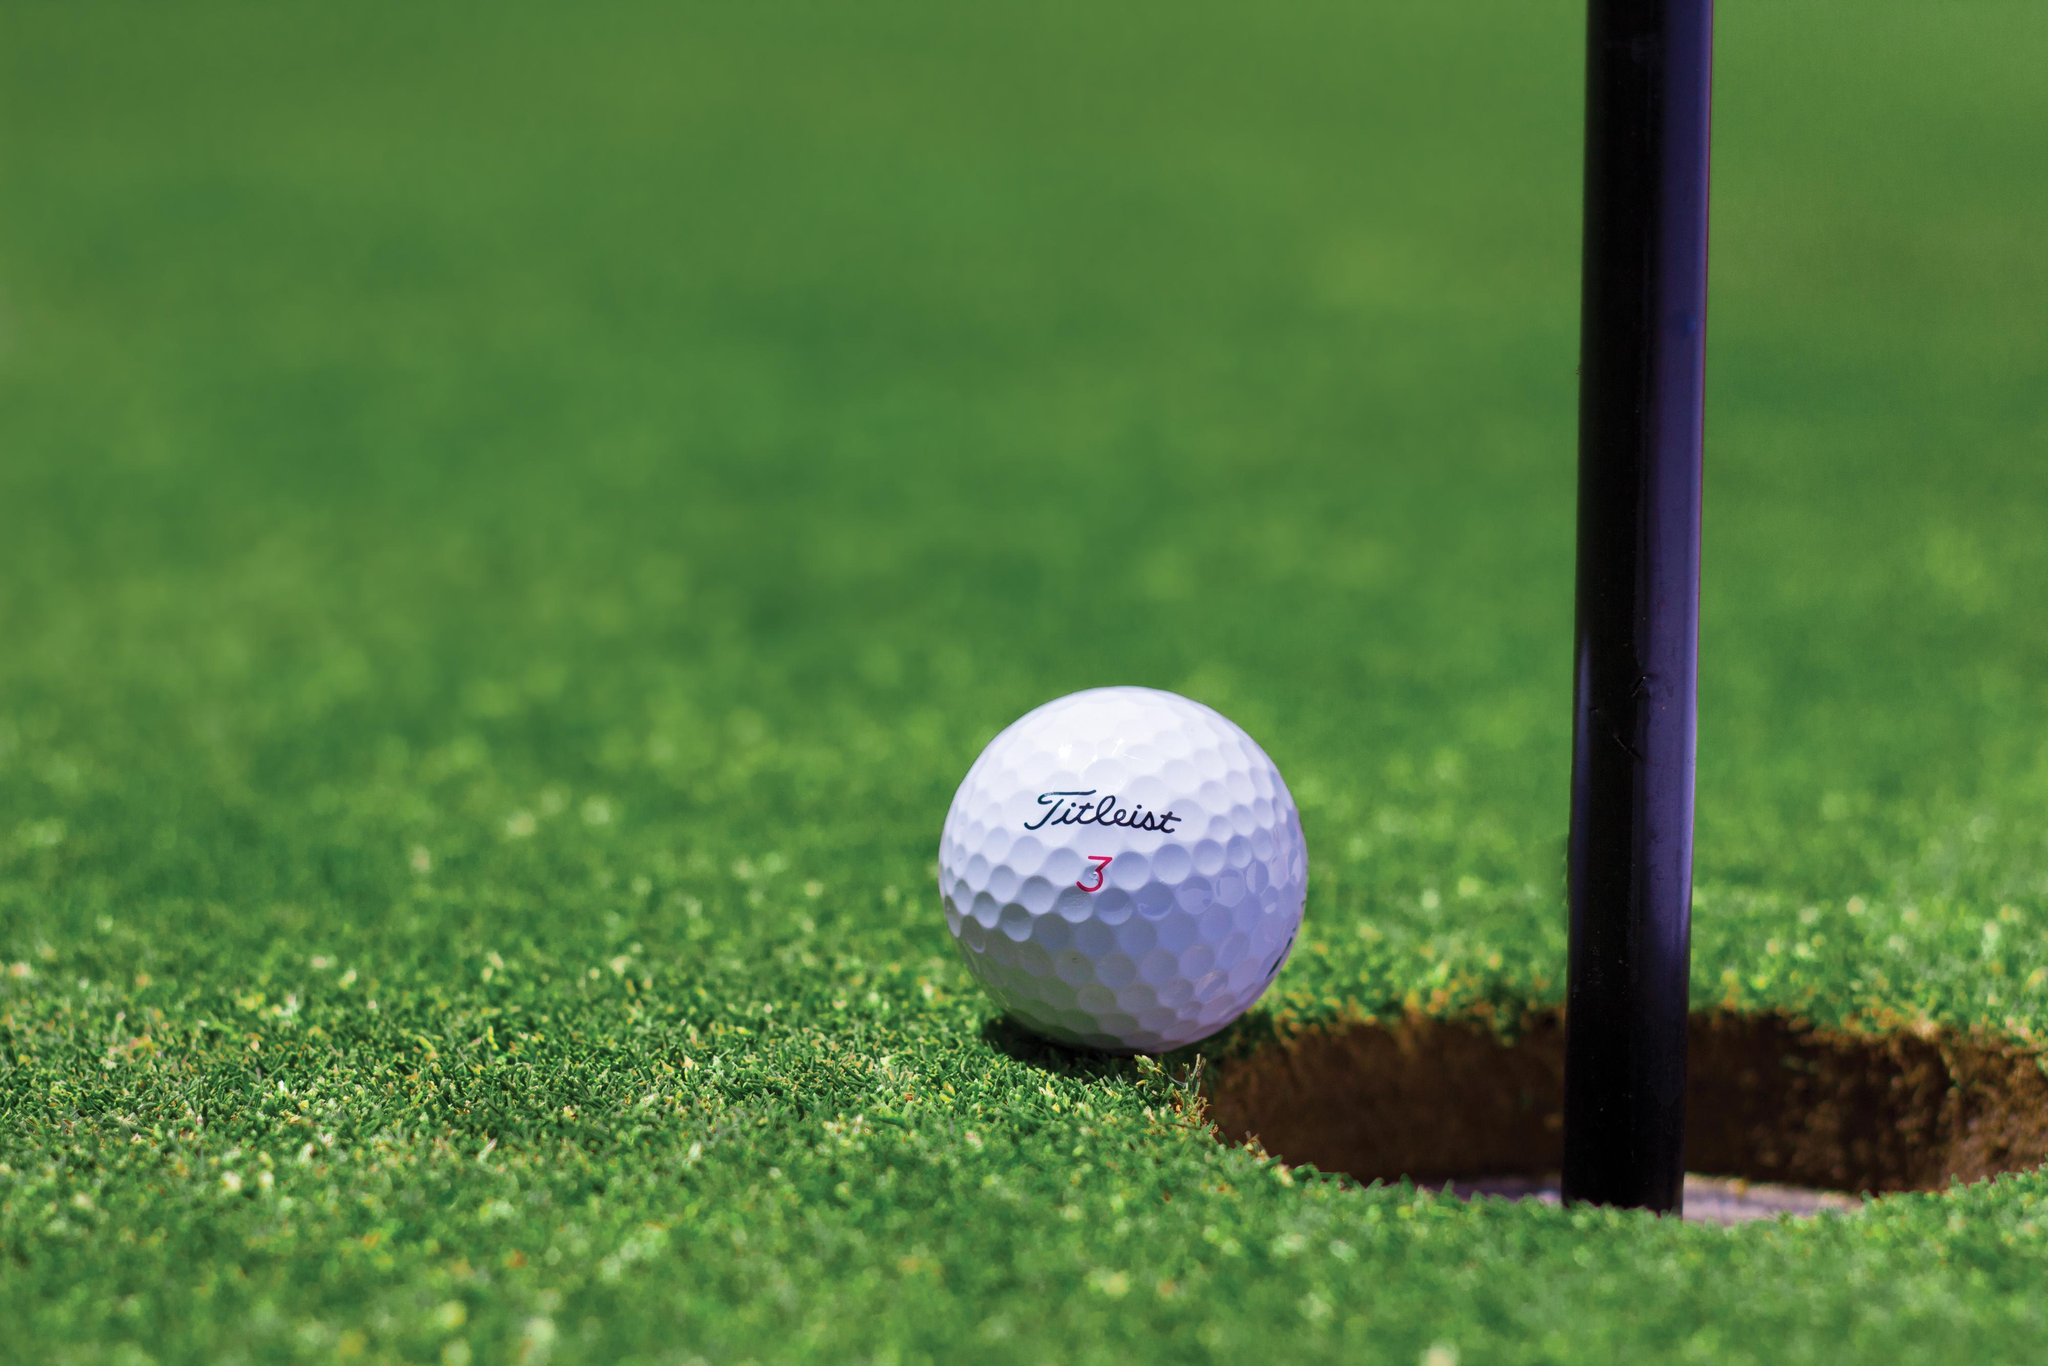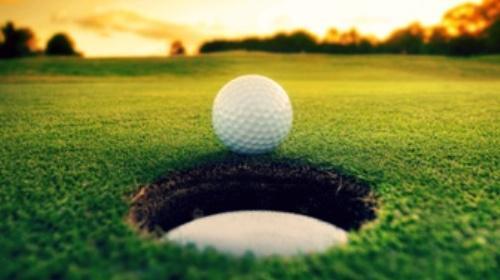The first image is the image on the left, the second image is the image on the right. Assess this claim about the two images: "In one of the images there is a golf ball on the very edge of a hole that has the flag pole in it.". Correct or not? Answer yes or no. Yes. 